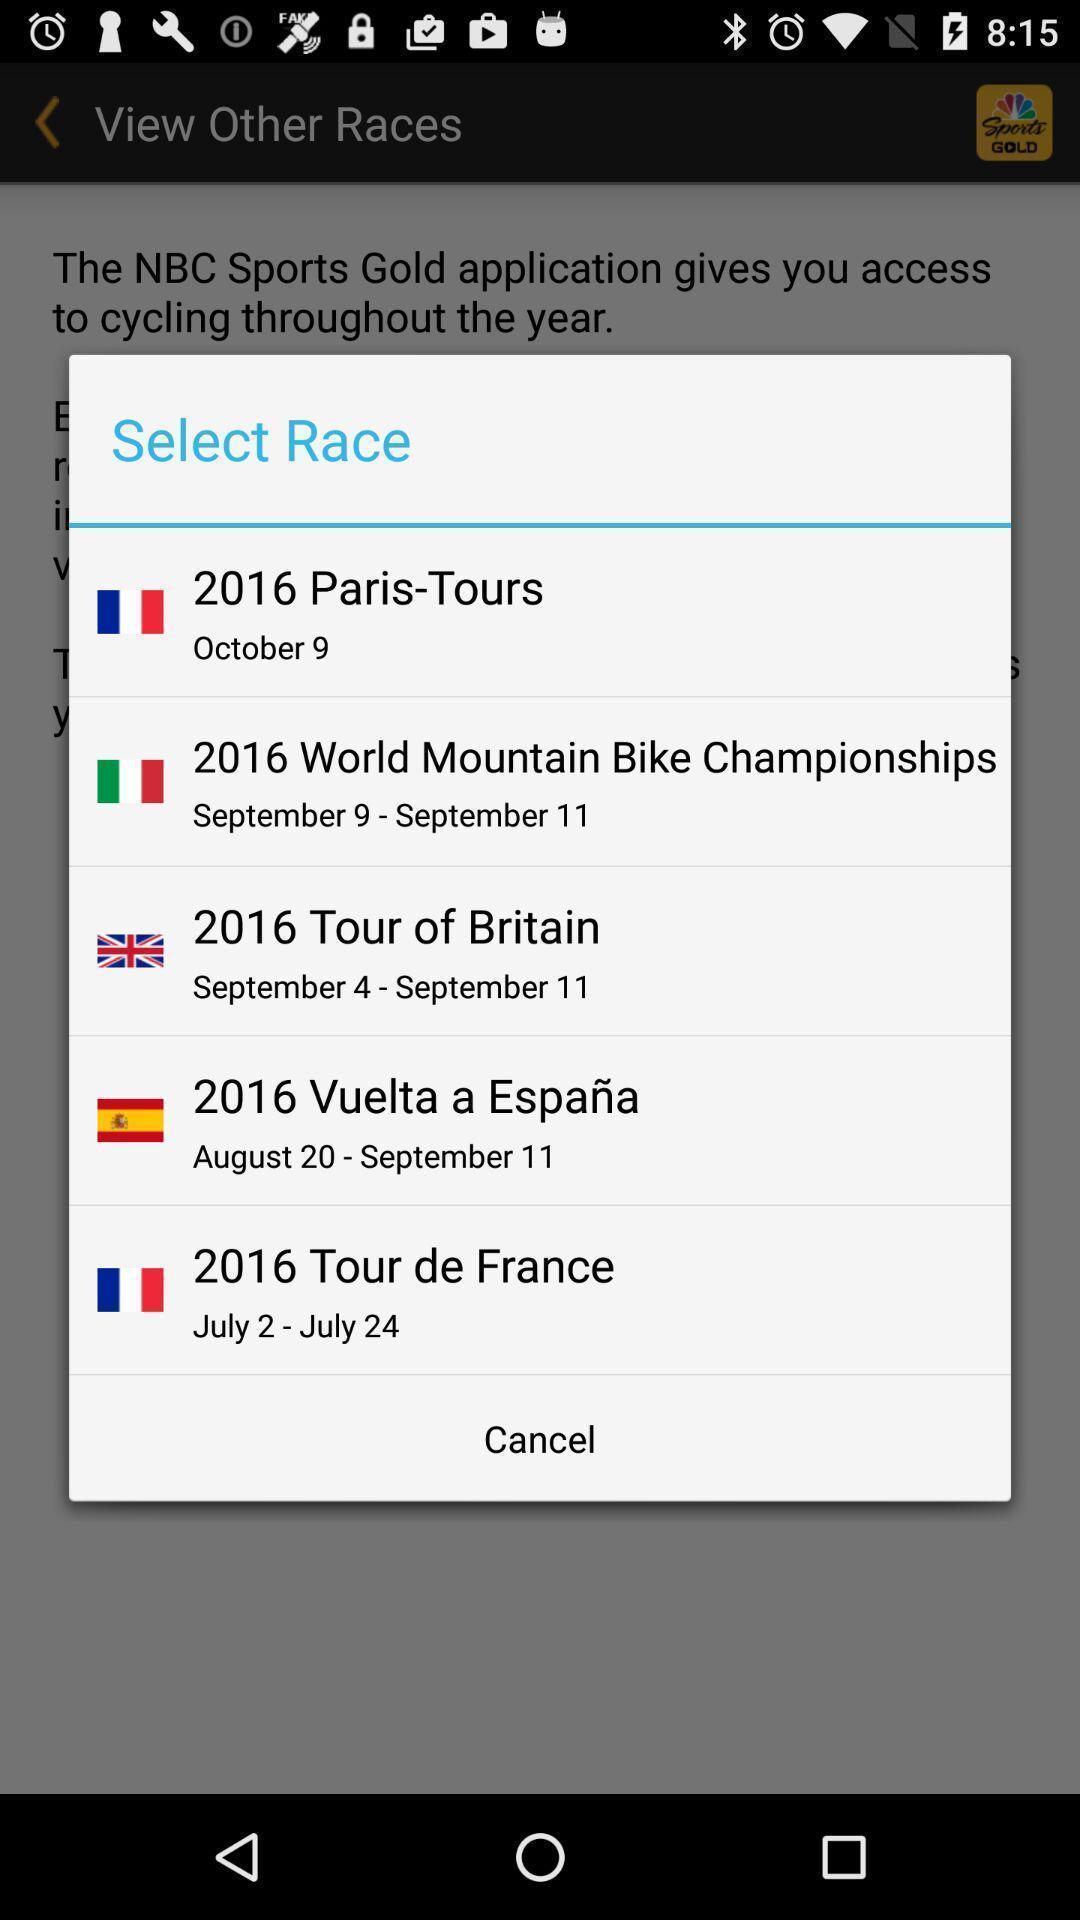Describe the key features of this screenshot. Pop up showing to select race in app. 